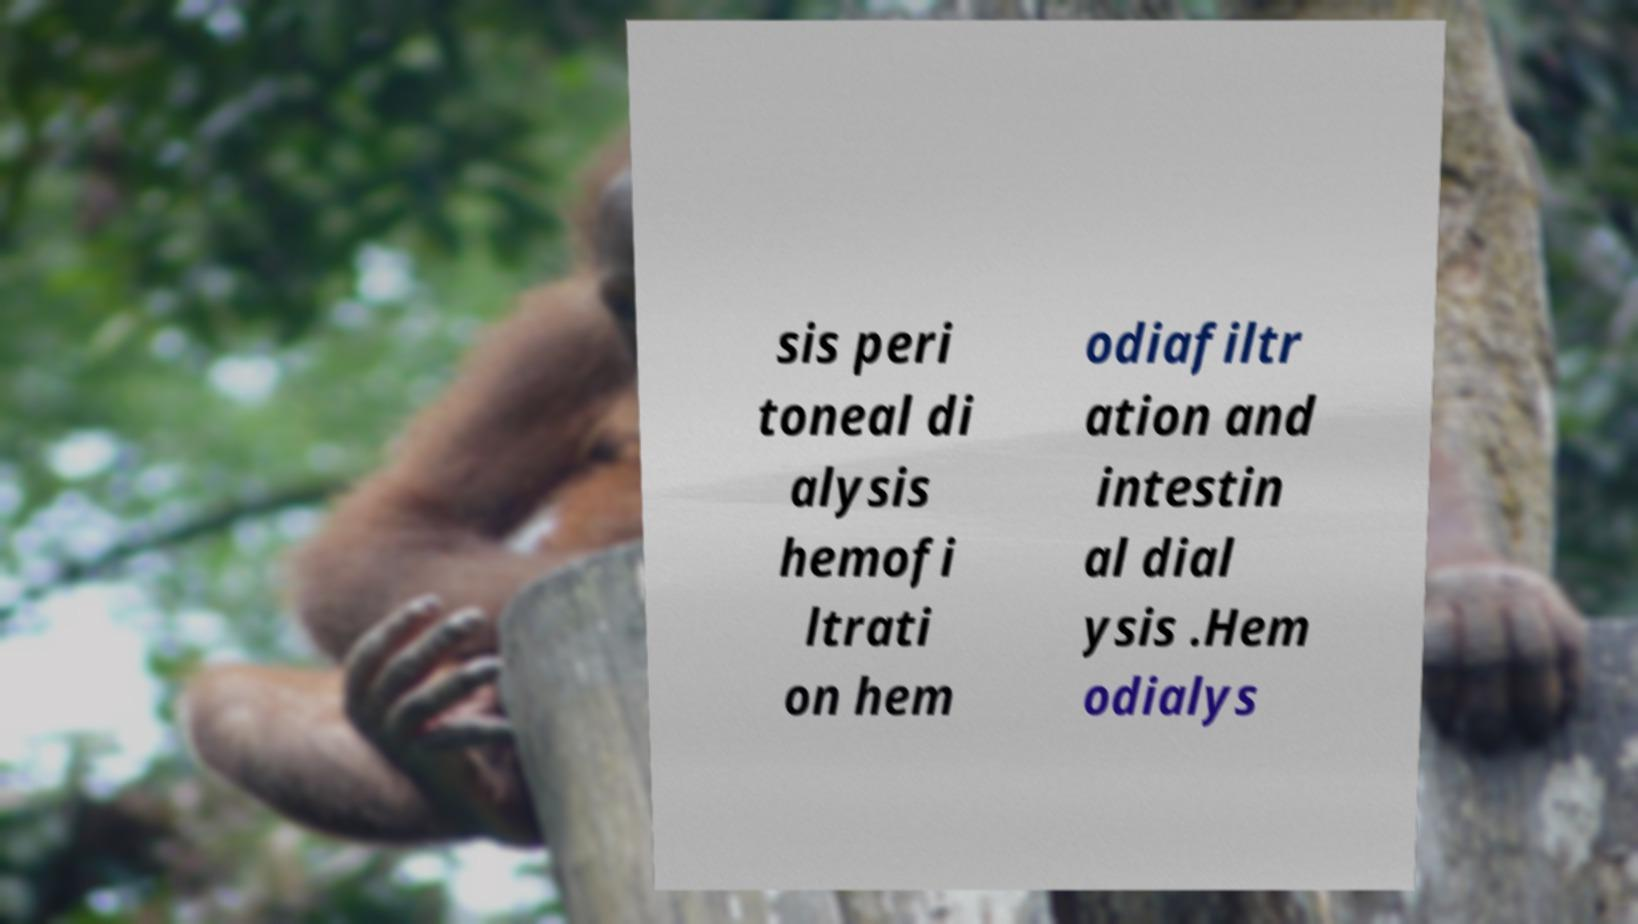Please read and relay the text visible in this image. What does it say? sis peri toneal di alysis hemofi ltrati on hem odiafiltr ation and intestin al dial ysis .Hem odialys 